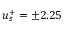<formula> <loc_0><loc_0><loc_500><loc_500>u _ { s } ^ { + } = \pm 2 . 2 5</formula> 